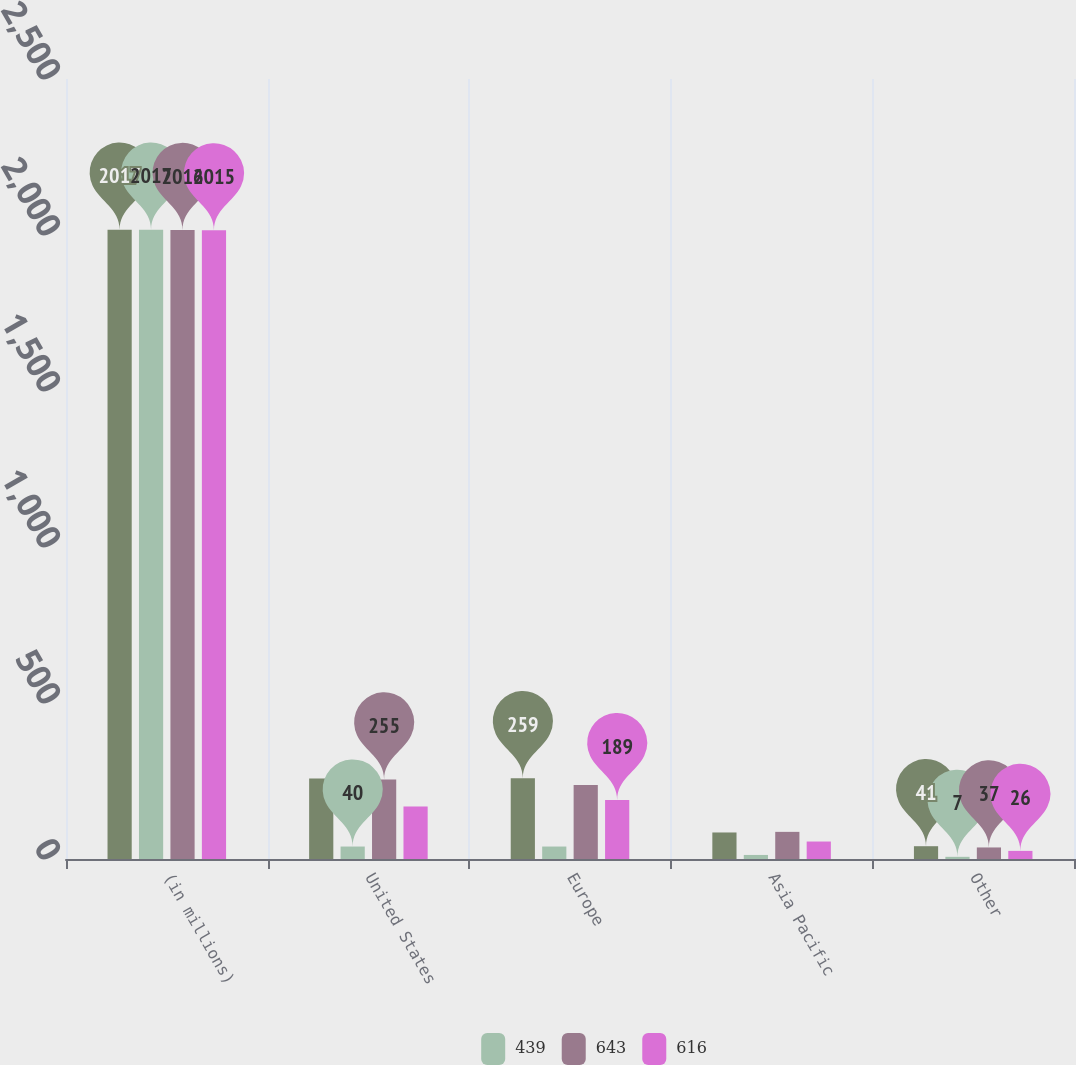Convert chart to OTSL. <chart><loc_0><loc_0><loc_500><loc_500><stacked_bar_chart><ecel><fcel>(in millions)<fcel>United States<fcel>Europe<fcel>Asia Pacific<fcel>Other<nl><fcel>nan<fcel>2017<fcel>258<fcel>259<fcel>85<fcel>41<nl><fcel>439<fcel>2017<fcel>40<fcel>40<fcel>13<fcel>7<nl><fcel>643<fcel>2016<fcel>255<fcel>237<fcel>87<fcel>37<nl><fcel>616<fcel>2015<fcel>168<fcel>189<fcel>56<fcel>26<nl></chart> 